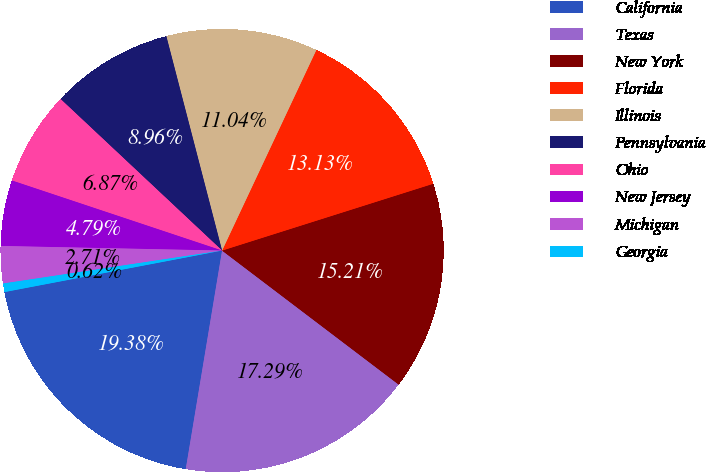Convert chart to OTSL. <chart><loc_0><loc_0><loc_500><loc_500><pie_chart><fcel>California<fcel>Texas<fcel>New York<fcel>Florida<fcel>Illinois<fcel>Pennsylvania<fcel>Ohio<fcel>New Jersey<fcel>Michigan<fcel>Georgia<nl><fcel>19.38%<fcel>17.29%<fcel>15.21%<fcel>13.13%<fcel>11.04%<fcel>8.96%<fcel>6.87%<fcel>4.79%<fcel>2.71%<fcel>0.62%<nl></chart> 